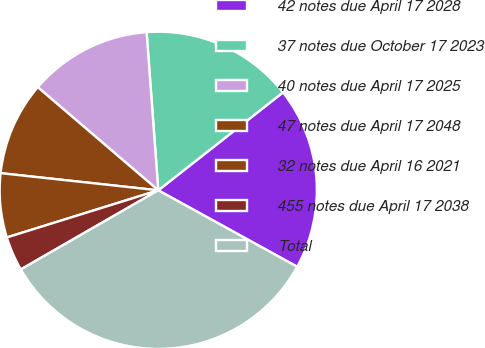Convert chart. <chart><loc_0><loc_0><loc_500><loc_500><pie_chart><fcel>42 notes due April 17 2028<fcel>37 notes due October 17 2023<fcel>40 notes due April 17 2025<fcel>47 notes due April 17 2048<fcel>32 notes due April 16 2021<fcel>455 notes due April 17 2038<fcel>Total<nl><fcel>18.6%<fcel>15.58%<fcel>12.56%<fcel>9.54%<fcel>6.53%<fcel>3.51%<fcel>33.68%<nl></chart> 